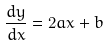Convert formula to latex. <formula><loc_0><loc_0><loc_500><loc_500>\frac { d y } { d x } = 2 a x + b</formula> 